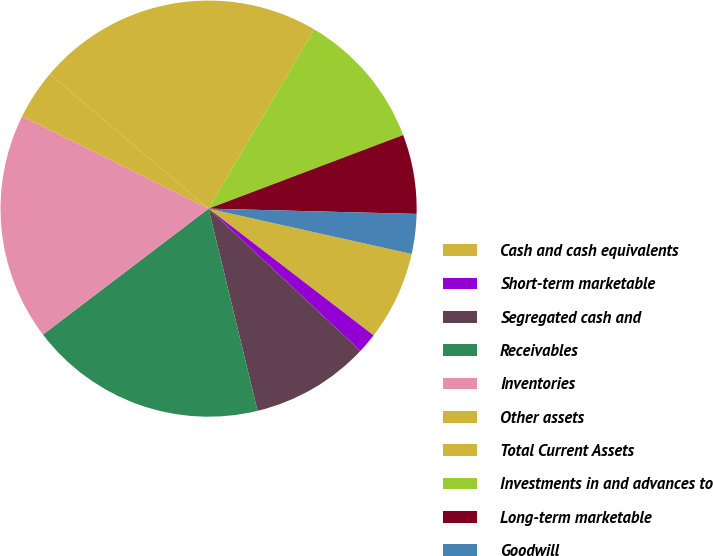<chart> <loc_0><loc_0><loc_500><loc_500><pie_chart><fcel>Cash and cash equivalents<fcel>Short-term marketable<fcel>Segregated cash and<fcel>Receivables<fcel>Inventories<fcel>Other assets<fcel>Total Current Assets<fcel>Investments in and advances to<fcel>Long-term marketable<fcel>Goodwill<nl><fcel>6.93%<fcel>1.56%<fcel>9.23%<fcel>18.44%<fcel>17.68%<fcel>3.86%<fcel>22.28%<fcel>10.77%<fcel>6.16%<fcel>3.09%<nl></chart> 